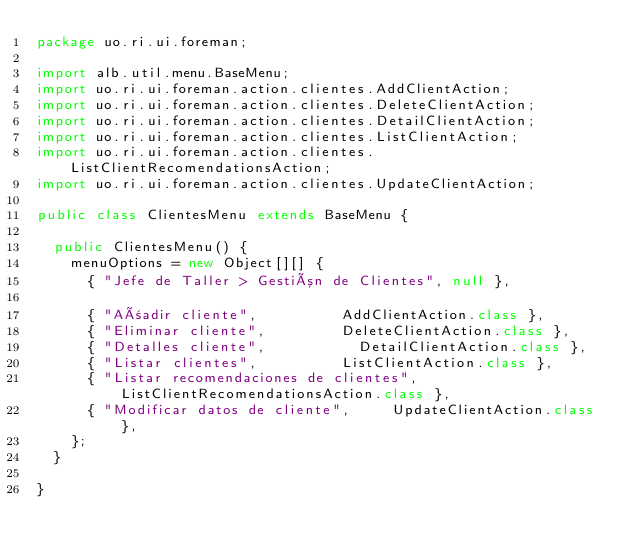<code> <loc_0><loc_0><loc_500><loc_500><_Java_>package uo.ri.ui.foreman;

import alb.util.menu.BaseMenu;
import uo.ri.ui.foreman.action.clientes.AddClientAction;
import uo.ri.ui.foreman.action.clientes.DeleteClientAction;
import uo.ri.ui.foreman.action.clientes.DetailClientAction;
import uo.ri.ui.foreman.action.clientes.ListClientAction;
import uo.ri.ui.foreman.action.clientes.ListClientRecomendationsAction;
import uo.ri.ui.foreman.action.clientes.UpdateClientAction;

public class ClientesMenu extends BaseMenu {

	public ClientesMenu() {
		menuOptions = new Object[][] { 
			{ "Jefe de Taller > Gestión de Clientes", null },

			{ "Añadir cliente", 					AddClientAction.class },  
			{ "Eliminar cliente",					DeleteClientAction.class },
			{ "Detalles cliente", 					DetailClientAction.class },
			{ "Listar clientes", 					ListClientAction.class },  
			{ "Listar recomendaciones de clientes", ListClientRecomendationsAction.class }, 
			{ "Modificar datos de cliente", 		UpdateClientAction.class }, 
		};
	}

}
</code> 